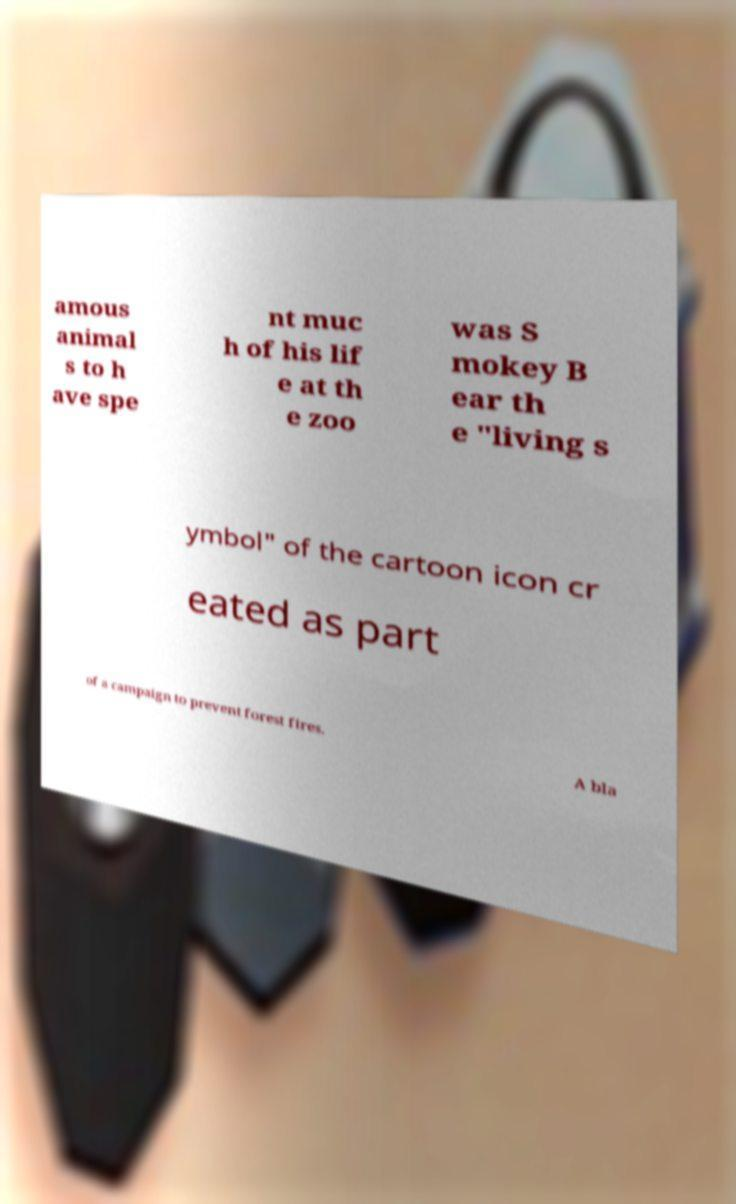I need the written content from this picture converted into text. Can you do that? amous animal s to h ave spe nt muc h of his lif e at th e zoo was S mokey B ear th e "living s ymbol" of the cartoon icon cr eated as part of a campaign to prevent forest fires. A bla 